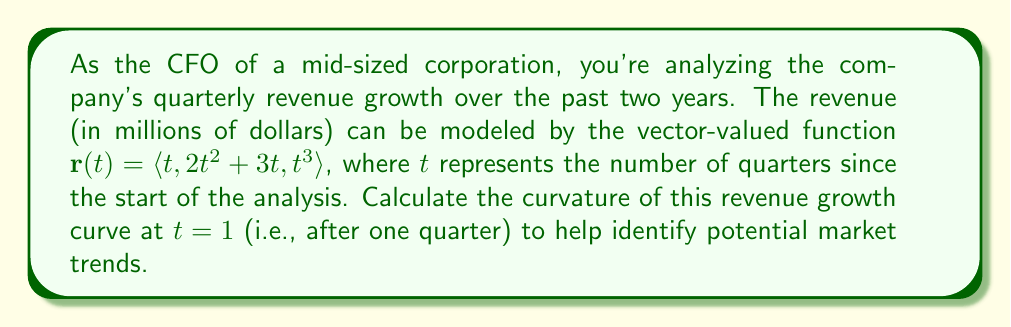Can you solve this math problem? To calculate the curvature of the revenue growth curve, we'll follow these steps:

1) The curvature formula for a vector-valued function is:

   $$\kappa = \frac{|\mathbf{r}'(t) \times \mathbf{r}''(t)|}{|\mathbf{r}'(t)|^3}$$

2) First, let's find $\mathbf{r}'(t)$:
   $$\mathbf{r}'(t) = \langle 1, 4t + 3, 3t^2 \rangle$$

3) Now, let's find $\mathbf{r}''(t)$:
   $$\mathbf{r}''(t) = \langle 0, 4, 6t \rangle$$

4) We need to calculate the cross product $\mathbf{r}'(t) \times \mathbf{r}''(t)$:
   $$\mathbf{r}'(t) \times \mathbf{r}''(t) = \langle (4t+3)(6t) - (3t^2)(4), (3t^2)(0) - (1)(6t), (1)(4) - (4t+3)(0) \rangle$$
   $$= \langle 24t^2 + 18t - 12t^2, -6t, 4 \rangle$$
   $$= \langle 12t^2 + 18t, -6t, 4 \rangle$$

5) Now, we evaluate at $t = 1$:
   $$\mathbf{r}'(1) = \langle 1, 7, 3 \rangle$$
   $$\mathbf{r}''(1) = \langle 0, 4, 6 \rangle$$
   $$\mathbf{r}'(1) \times \mathbf{r}''(1) = \langle 30, -6, 4 \rangle$$

6) Calculate $|\mathbf{r}'(1) \times \mathbf{r}''(1)|$:
   $$|\mathbf{r}'(1) \times \mathbf{r}''(1)| = \sqrt{30^2 + (-6)^2 + 4^2} = \sqrt{936} = 2\sqrt{234}$$

7) Calculate $|\mathbf{r}'(1)|$:
   $$|\mathbf{r}'(1)| = \sqrt{1^2 + 7^2 + 3^2} = \sqrt{59}$$

8) Now we can plug these values into the curvature formula:
   $$\kappa = \frac{2\sqrt{234}}{(\sqrt{59})^3} = \frac{2\sqrt{234}}{59\sqrt{59}}$$

This is our final answer, but we can simplify it slightly:
   $$\kappa = \frac{2\sqrt{3926}}{59\sqrt{59}} = \frac{2\sqrt{66.542}}{59\sqrt{59}} \approx 0.0382$$
Answer: The curvature of the revenue growth curve at $t = 1$ is $\frac{2\sqrt{3926}}{59\sqrt{59}} \approx 0.0382$. 